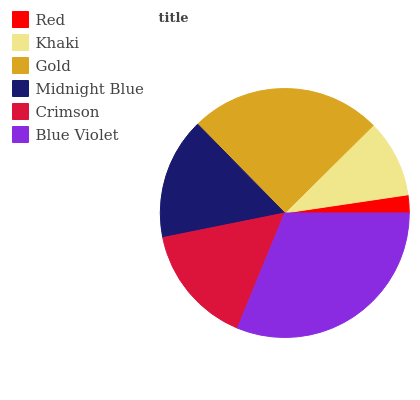Is Red the minimum?
Answer yes or no. Yes. Is Blue Violet the maximum?
Answer yes or no. Yes. Is Khaki the minimum?
Answer yes or no. No. Is Khaki the maximum?
Answer yes or no. No. Is Khaki greater than Red?
Answer yes or no. Yes. Is Red less than Khaki?
Answer yes or no. Yes. Is Red greater than Khaki?
Answer yes or no. No. Is Khaki less than Red?
Answer yes or no. No. Is Midnight Blue the high median?
Answer yes or no. Yes. Is Crimson the low median?
Answer yes or no. Yes. Is Khaki the high median?
Answer yes or no. No. Is Red the low median?
Answer yes or no. No. 